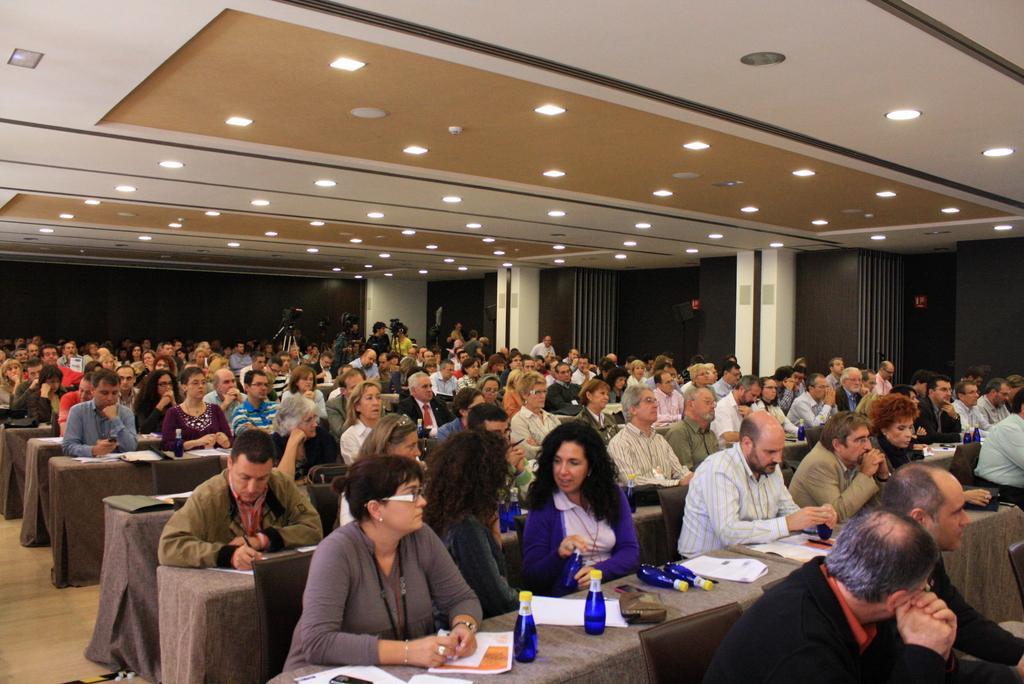In one or two sentences, can you explain what this image depicts? There are many people in the image. In the middle there is a table on that table there are many bottles and papers ,table is covered with a cloth. In the background there are cameras ,wall,pillar and light. 